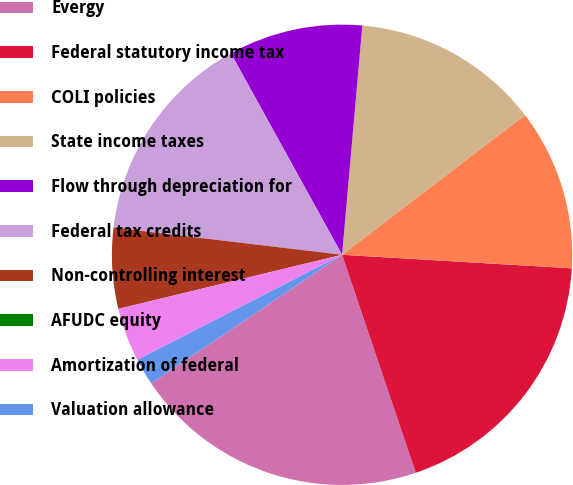<chart> <loc_0><loc_0><loc_500><loc_500><pie_chart><fcel>Evergy<fcel>Federal statutory income tax<fcel>COLI policies<fcel>State income taxes<fcel>Flow through depreciation for<fcel>Federal tax credits<fcel>Non-controlling interest<fcel>AFUDC equity<fcel>Amortization of federal<fcel>Valuation allowance<nl><fcel>20.75%<fcel>18.87%<fcel>11.32%<fcel>13.21%<fcel>9.43%<fcel>15.09%<fcel>5.66%<fcel>0.0%<fcel>3.77%<fcel>1.89%<nl></chart> 